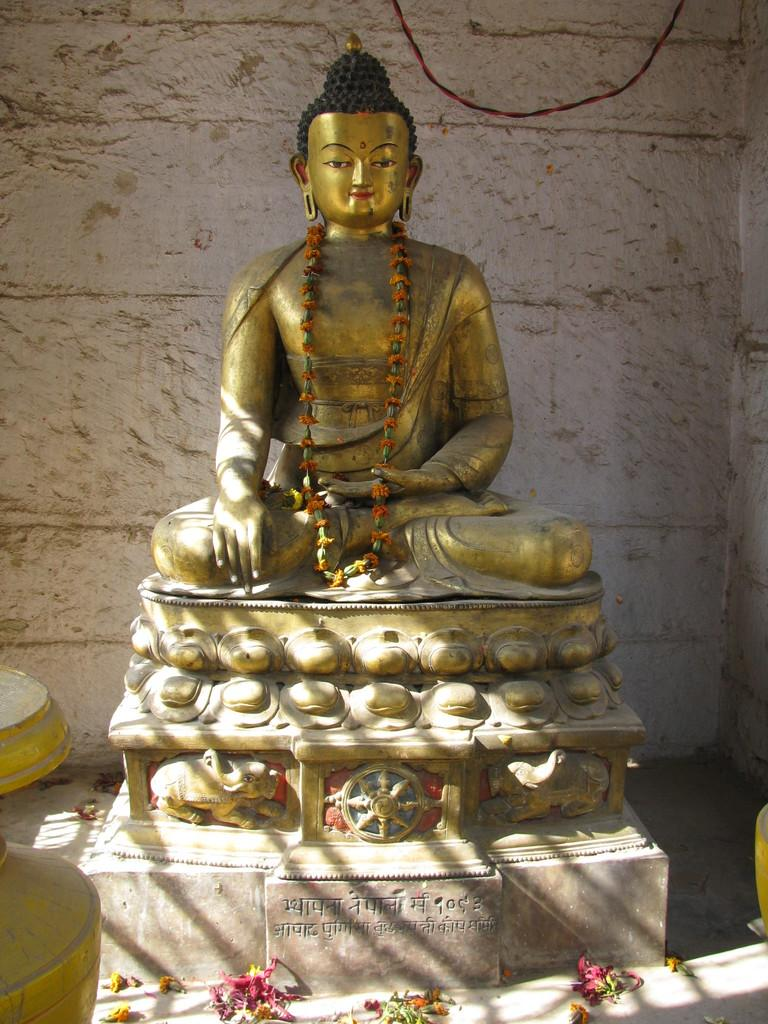What is the main subject of the image? There is a statue of Buddha in the image. What is the color of the statue? The statue is gold in color. What other objects can be seen in the image? There are flowers in the image. What can be seen in the background of the image? There is a wall and a wire in the background of the image. How many times does the statue roll down the hill in the image? There is no hill or rolling statue in the image; it features a gold statue of Buddha with flowers and a background of a wall and a wire. What type of sorting algorithm is being used by the flowers in the image? The flowers in the image are not performing any sorting algorithm; they are simply present as decorative objects. 